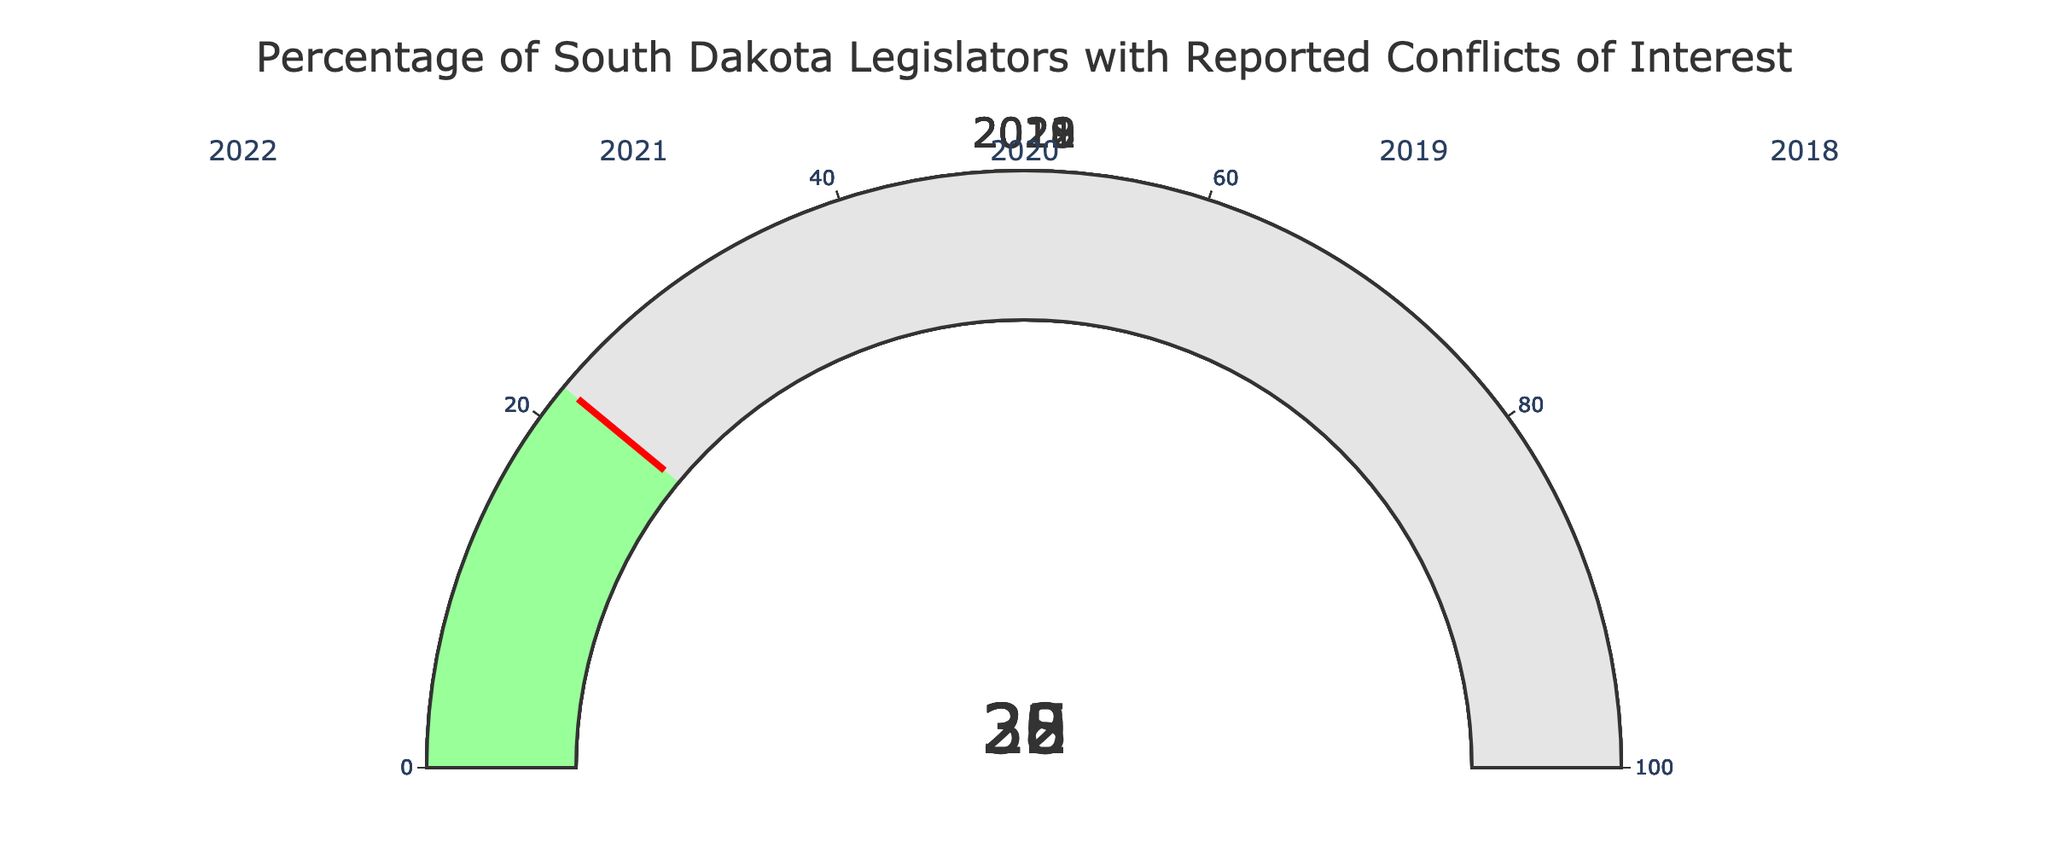what percentage of South Dakota legislators had reported conflicts of interest in 2022? To find this, look at the gauge titled "2022" in the chart. The number displayed on the gauge indicates the percentage.
Answer: 28 What is the title of the figure? The title is usually placed at the top of the figure. For this specific chart, it is located centrally.
Answer: Percentage of South Dakota Legislators with Reported Conflicts of Interest What is the trend in the percentage of legislators with reported conflicts of interest from 2018 to 2022? Observe the sequence of values shown in the gauges from 2018 to 2022 and describe the pattern. The values are 22%, 30%, 25%, 32%, and 28%. This shows a fluctuating trend without a consistent increase or decrease.
Answer: Fluctuating What is the average percentage of reported conflicts of interest over the five years? Add the percentages for all five years and divide by the number of years: (22 + 30 + 25 + 32 + 28) / 5.
Answer: 27.4 Which year had the highest percentage of reported conflicts of interest? Compare the values shown on each gauge. Identify the year with the highest number. The values are 22%, 30%, 25%, 32%, and 28%, so the highest is 32% in 2021.
Answer: 2021 Is the percentage of reported conflicts of interest greater in 2020 or 2022? Compare the percentages shown for 2020 and 2022 in the respective gauges. 2020 is 25% and 2022 is 28%.
Answer: 2022 What is the difference in the percentage of reported conflicts of interest between 2018 and 2021? Subtract the percentage in 2018 from the percentage in 2021: 32 - 22.
Answer: 10 Which year had the lowest percentage of reported conflicts of interest? Compare the values shown on each gauge. Identify the year with the lowest number. The values are 22%, 30%, 25%, 32%, and 28%, so the lowest is 22% in 2018.
Answer: 2018 What is the typical range of percentages shown on these gauges? The lowest percentage is 22% (2018), and the highest is 32% (2021). The range is from 22% to 32%.
Answer: 22% to 32% Across all five years, how many times does the percentage exceed 25%? Count the gauges with values above 25%. The values are 22%, 30%, 25%, 32%, and 28%. The years exceeding 25% are 2019, 2021, and 2022.
Answer: 3 